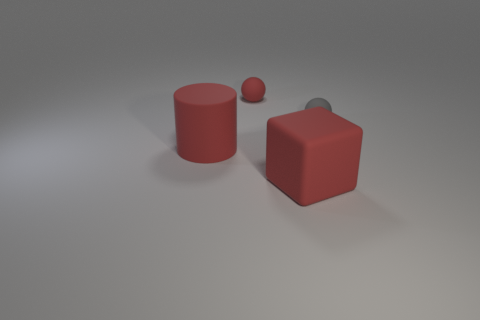Add 4 tiny green shiny cubes. How many objects exist? 8 Subtract all cubes. How many objects are left? 3 Subtract all gray objects. Subtract all small blue blocks. How many objects are left? 3 Add 1 large things. How many large things are left? 3 Add 4 big red matte cubes. How many big red matte cubes exist? 5 Subtract 0 green blocks. How many objects are left? 4 